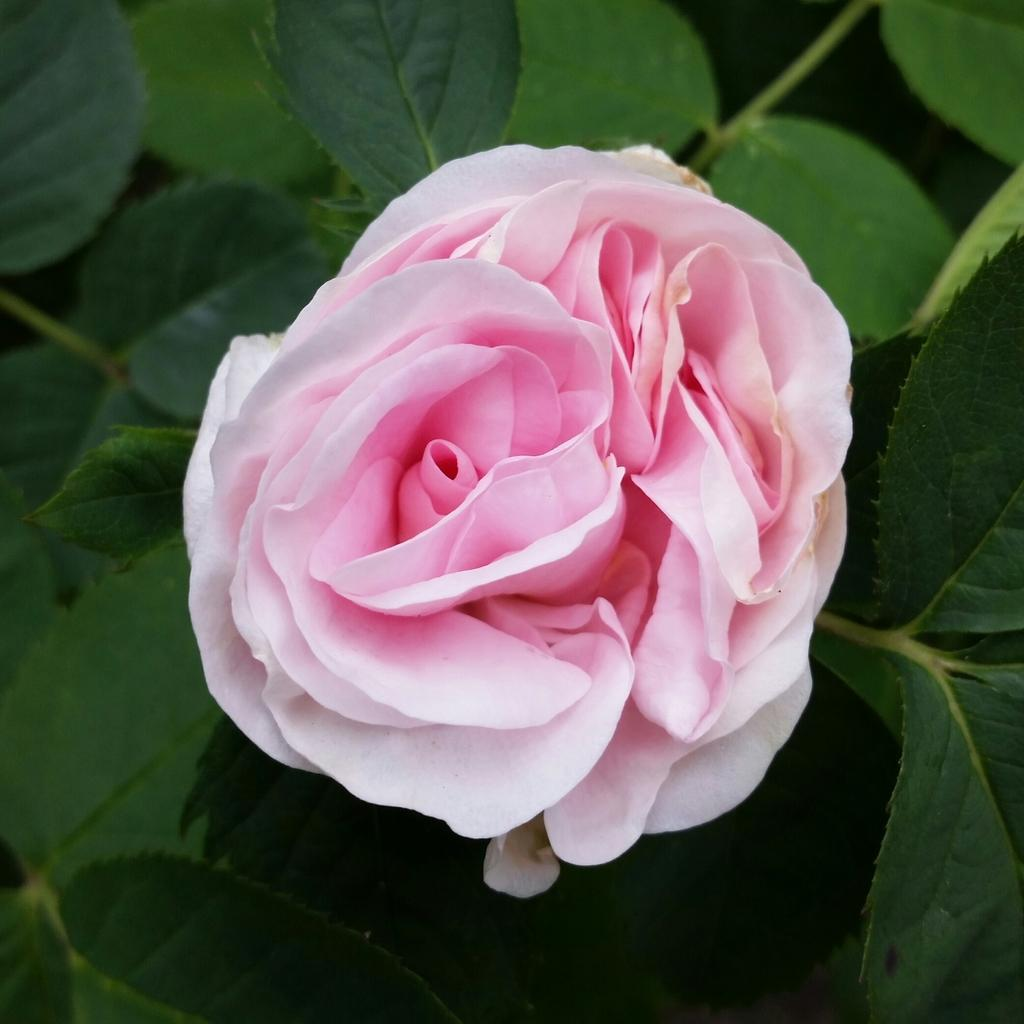What is the main subject of the picture? The main subject of the picture is a flower. Can you describe the color of the flower? The flower is pink in color. What else can be seen around the flower in the picture? There are green leaves below the flower. What type of payment method is accepted in the flower's lunchroom? There is no mention of a lunchroom or payment method in the image, as it only features a pink flower with green leaves. 